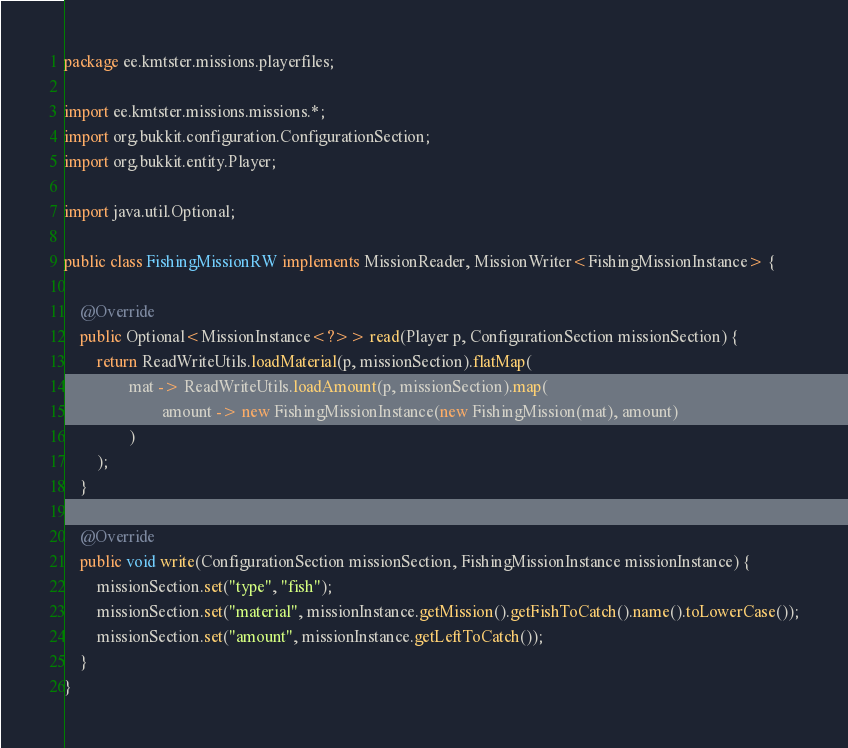<code> <loc_0><loc_0><loc_500><loc_500><_Java_>package ee.kmtster.missions.playerfiles;

import ee.kmtster.missions.missions.*;
import org.bukkit.configuration.ConfigurationSection;
import org.bukkit.entity.Player;

import java.util.Optional;

public class FishingMissionRW implements MissionReader, MissionWriter<FishingMissionInstance> {

    @Override
    public Optional<MissionInstance<?>> read(Player p, ConfigurationSection missionSection) {
        return ReadWriteUtils.loadMaterial(p, missionSection).flatMap(
                mat -> ReadWriteUtils.loadAmount(p, missionSection).map(
                        amount -> new FishingMissionInstance(new FishingMission(mat), amount)
                )
        );
    }

    @Override
    public void write(ConfigurationSection missionSection, FishingMissionInstance missionInstance) {
        missionSection.set("type", "fish");
        missionSection.set("material", missionInstance.getMission().getFishToCatch().name().toLowerCase());
        missionSection.set("amount", missionInstance.getLeftToCatch());
    }
}
</code> 